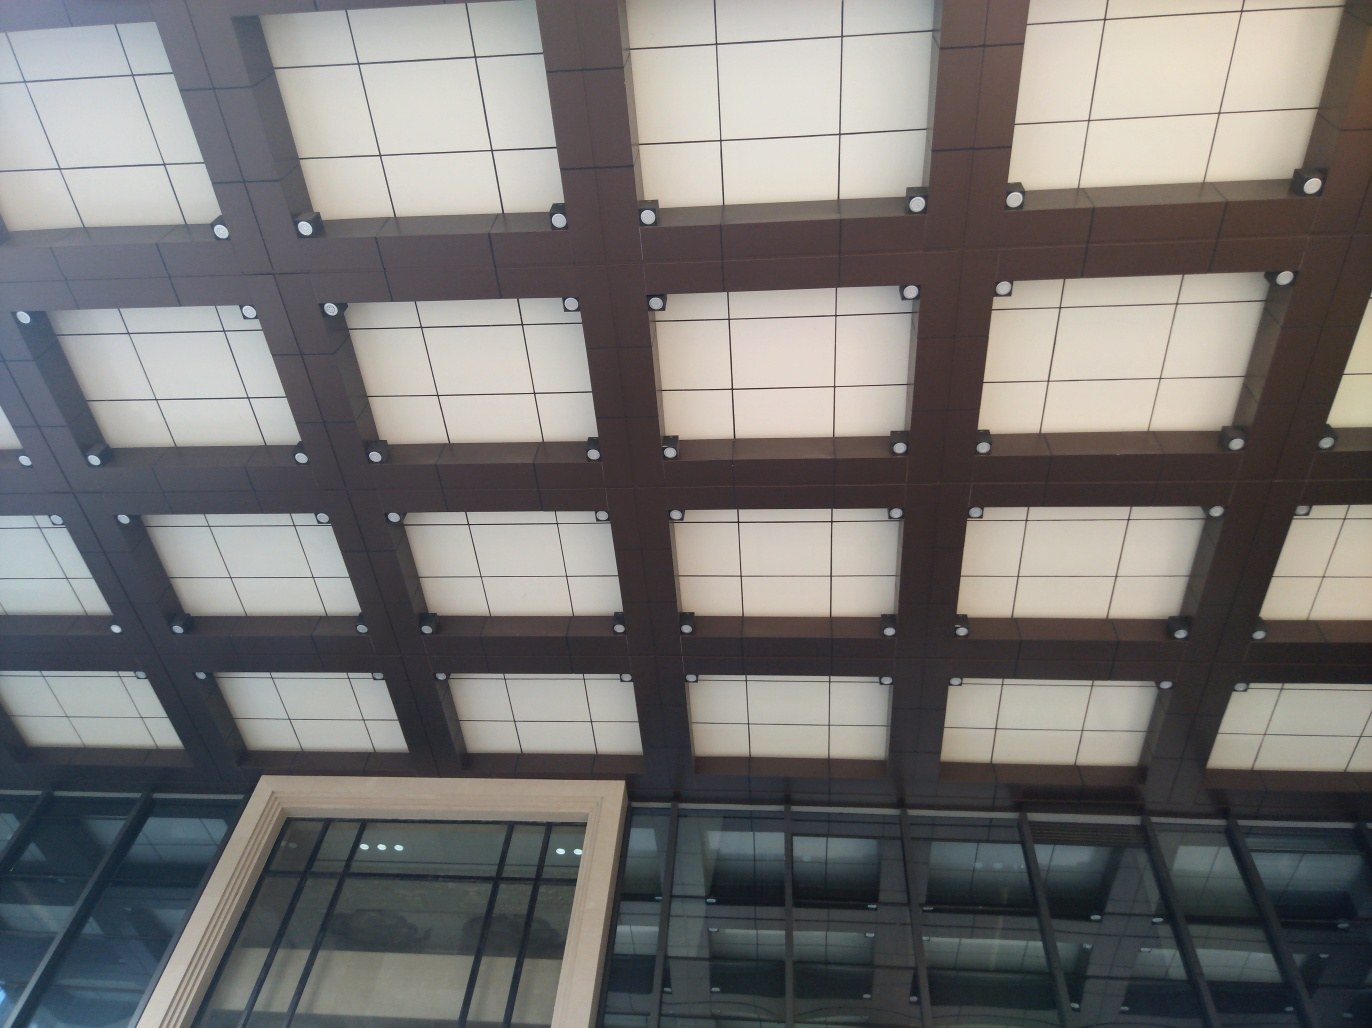What is the main subject of the image? The main subject of the image is a geometric pattern of square ceiling panels, varying between lighter and darker shades, installed in a grid-like structure. This appears to be part of an interior architectural design, providing both aesthetic and functional value. 